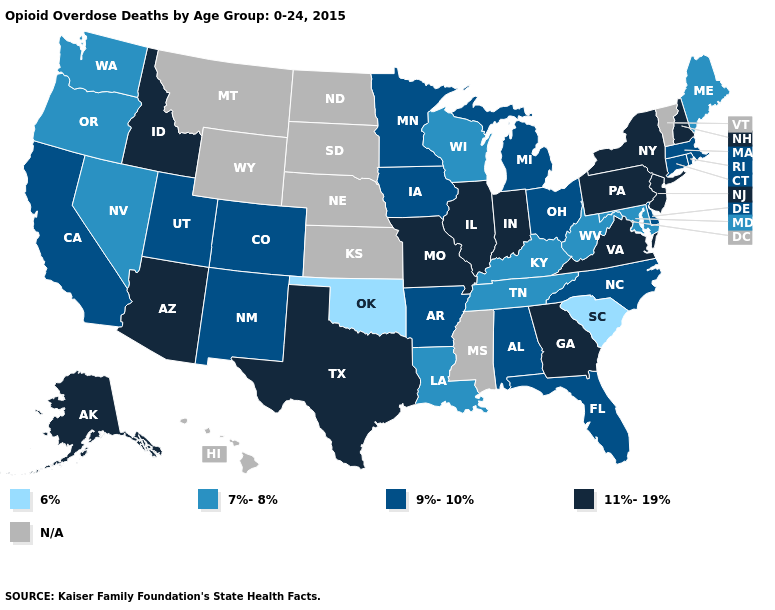What is the lowest value in the USA?
Answer briefly. 6%. Does Connecticut have the highest value in the Northeast?
Short answer required. No. What is the lowest value in the West?
Be succinct. 7%-8%. Does Wisconsin have the lowest value in the MidWest?
Write a very short answer. Yes. What is the value of Oklahoma?
Quick response, please. 6%. Name the states that have a value in the range 9%-10%?
Give a very brief answer. Alabama, Arkansas, California, Colorado, Connecticut, Delaware, Florida, Iowa, Massachusetts, Michigan, Minnesota, New Mexico, North Carolina, Ohio, Rhode Island, Utah. What is the value of Virginia?
Answer briefly. 11%-19%. Name the states that have a value in the range 7%-8%?
Write a very short answer. Kentucky, Louisiana, Maine, Maryland, Nevada, Oregon, Tennessee, Washington, West Virginia, Wisconsin. What is the highest value in the MidWest ?
Quick response, please. 11%-19%. What is the highest value in the MidWest ?
Write a very short answer. 11%-19%. Does Rhode Island have the highest value in the Northeast?
Answer briefly. No. Among the states that border North Dakota , which have the highest value?
Concise answer only. Minnesota. How many symbols are there in the legend?
Concise answer only. 5. What is the lowest value in the USA?
Keep it brief. 6%. 